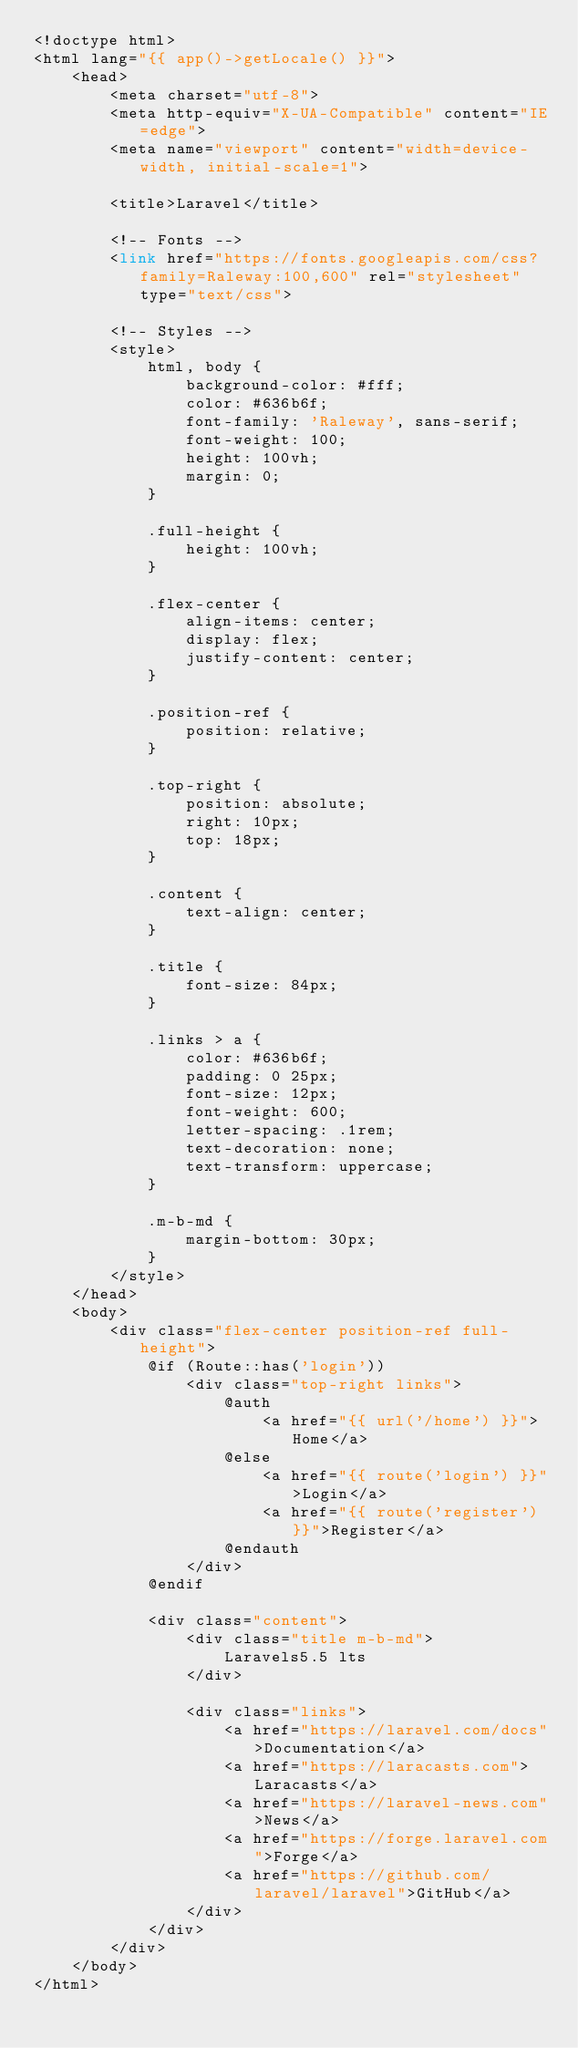<code> <loc_0><loc_0><loc_500><loc_500><_PHP_><!doctype html>
<html lang="{{ app()->getLocale() }}">
    <head>
        <meta charset="utf-8">
        <meta http-equiv="X-UA-Compatible" content="IE=edge">
        <meta name="viewport" content="width=device-width, initial-scale=1">

        <title>Laravel</title>

        <!-- Fonts -->
        <link href="https://fonts.googleapis.com/css?family=Raleway:100,600" rel="stylesheet" type="text/css">

        <!-- Styles -->
        <style>
            html, body {
                background-color: #fff;
                color: #636b6f;
                font-family: 'Raleway', sans-serif;
                font-weight: 100;
                height: 100vh;
                margin: 0;
            }

            .full-height {
                height: 100vh;
            }

            .flex-center {
                align-items: center;
                display: flex;
                justify-content: center;
            }

            .position-ref {
                position: relative;
            }

            .top-right {
                position: absolute;
                right: 10px;
                top: 18px;
            }

            .content {
                text-align: center;
            }

            .title {
                font-size: 84px;
            }

            .links > a {
                color: #636b6f;
                padding: 0 25px;
                font-size: 12px;
                font-weight: 600;
                letter-spacing: .1rem;
                text-decoration: none;
                text-transform: uppercase;
            }

            .m-b-md {
                margin-bottom: 30px;
            }
        </style>
    </head>
    <body>
        <div class="flex-center position-ref full-height">
            @if (Route::has('login'))
                <div class="top-right links">
                    @auth
                        <a href="{{ url('/home') }}">Home</a>
                    @else
                        <a href="{{ route('login') }}">Login</a>
                        <a href="{{ route('register') }}">Register</a>
                    @endauth
                </div>
            @endif

            <div class="content">
                <div class="title m-b-md">
                    Laravels5.5 lts
                </div>

                <div class="links">
                    <a href="https://laravel.com/docs">Documentation</a>
                    <a href="https://laracasts.com">Laracasts</a>
                    <a href="https://laravel-news.com">News</a>
                    <a href="https://forge.laravel.com">Forge</a>
                    <a href="https://github.com/laravel/laravel">GitHub</a>
                </div>
            </div>
        </div>
    </body>
</html>
</code> 